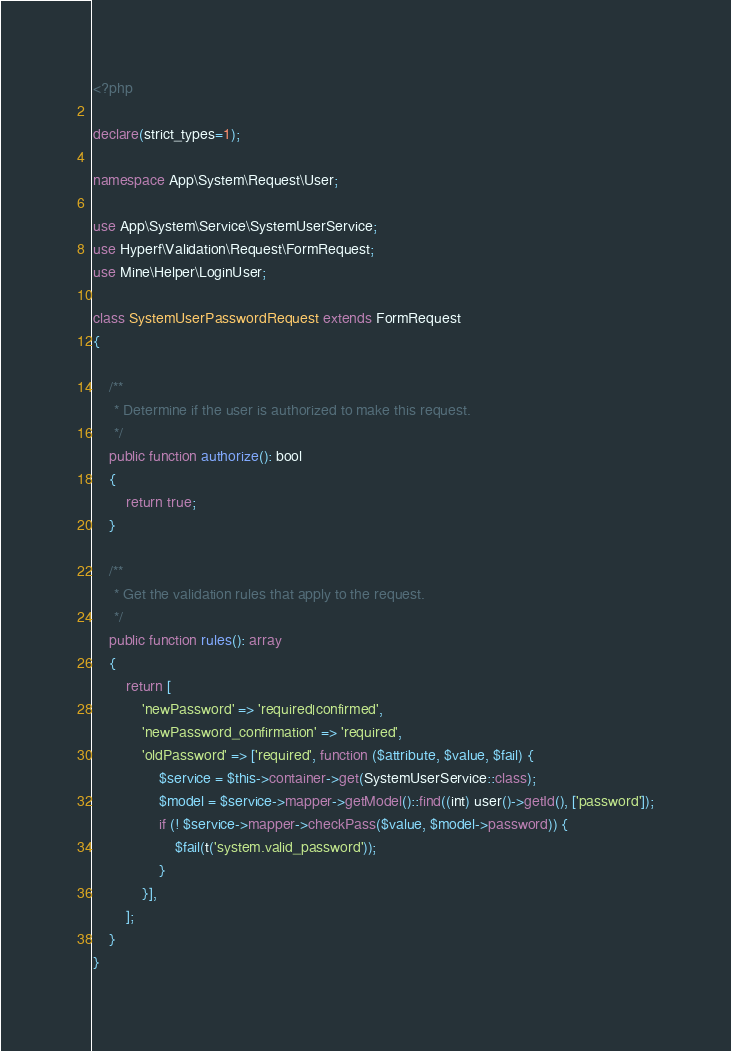Convert code to text. <code><loc_0><loc_0><loc_500><loc_500><_PHP_><?php

declare(strict_types=1);

namespace App\System\Request\User;

use App\System\Service\SystemUserService;
use Hyperf\Validation\Request\FormRequest;
use Mine\Helper\LoginUser;

class SystemUserPasswordRequest extends FormRequest
{

    /**
     * Determine if the user is authorized to make this request.
     */
    public function authorize(): bool
    {
        return true;
    }

    /**
     * Get the validation rules that apply to the request.
     */
    public function rules(): array
    {
        return [
            'newPassword' => 'required|confirmed',
            'newPassword_confirmation' => 'required',
            'oldPassword' => ['required', function ($attribute, $value, $fail) {
                $service = $this->container->get(SystemUserService::class);
                $model = $service->mapper->getModel()::find((int) user()->getId(), ['password']);
                if (! $service->mapper->checkPass($value, $model->password)) {
                    $fail(t('system.valid_password'));
                }
            }],
        ];
    }
}
</code> 